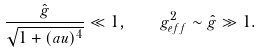Convert formula to latex. <formula><loc_0><loc_0><loc_500><loc_500>\frac { \hat { g } } { \sqrt { 1 + ( a u ) ^ { 4 } } } \ll 1 , \quad g _ { e f f } ^ { 2 } \sim \hat { g } \gg 1 .</formula> 